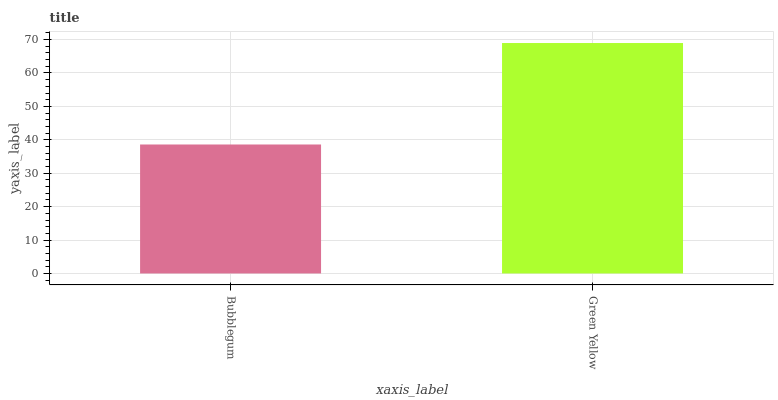Is Green Yellow the minimum?
Answer yes or no. No. Is Green Yellow greater than Bubblegum?
Answer yes or no. Yes. Is Bubblegum less than Green Yellow?
Answer yes or no. Yes. Is Bubblegum greater than Green Yellow?
Answer yes or no. No. Is Green Yellow less than Bubblegum?
Answer yes or no. No. Is Green Yellow the high median?
Answer yes or no. Yes. Is Bubblegum the low median?
Answer yes or no. Yes. Is Bubblegum the high median?
Answer yes or no. No. Is Green Yellow the low median?
Answer yes or no. No. 